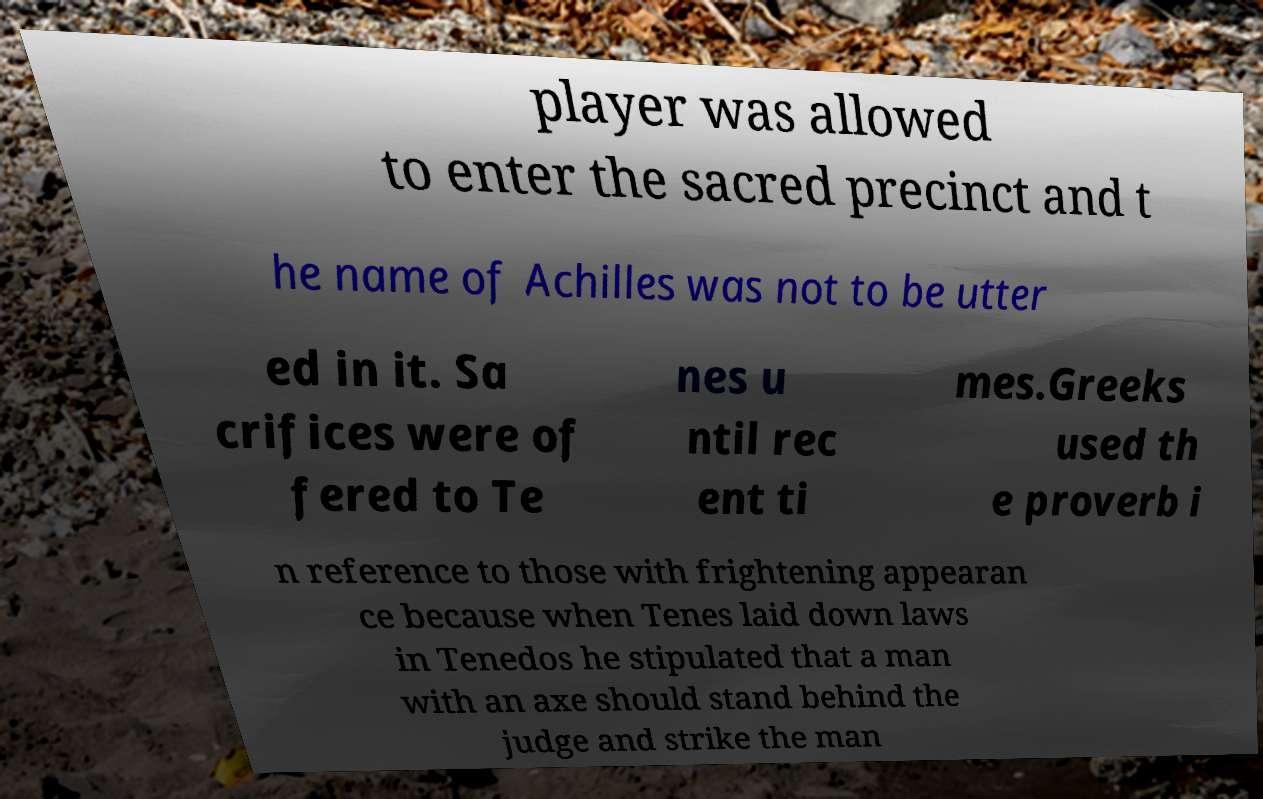Please read and relay the text visible in this image. What does it say? player was allowed to enter the sacred precinct and t he name of Achilles was not to be utter ed in it. Sa crifices were of fered to Te nes u ntil rec ent ti mes.Greeks used th e proverb i n reference to those with frightening appearan ce because when Tenes laid down laws in Tenedos he stipulated that a man with an axe should stand behind the judge and strike the man 